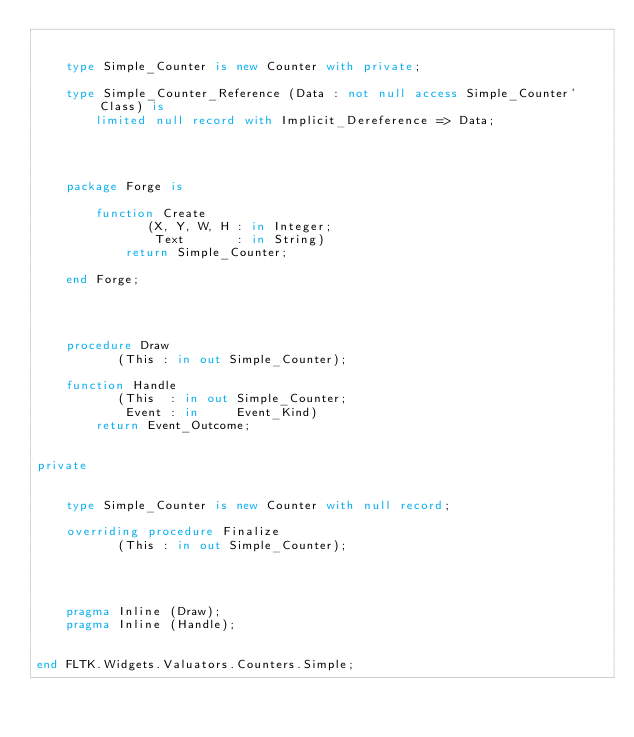<code> <loc_0><loc_0><loc_500><loc_500><_Ada_>

    type Simple_Counter is new Counter with private;

    type Simple_Counter_Reference (Data : not null access Simple_Counter'Class) is
        limited null record with Implicit_Dereference => Data;




    package Forge is

        function Create
               (X, Y, W, H : in Integer;
                Text       : in String)
            return Simple_Counter;

    end Forge;




    procedure Draw
           (This : in out Simple_Counter);

    function Handle
           (This  : in out Simple_Counter;
            Event : in     Event_Kind)
        return Event_Outcome;


private


    type Simple_Counter is new Counter with null record;

    overriding procedure Finalize
           (This : in out Simple_Counter);




    pragma Inline (Draw);
    pragma Inline (Handle);


end FLTK.Widgets.Valuators.Counters.Simple;

</code> 